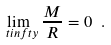Convert formula to latex. <formula><loc_0><loc_0><loc_500><loc_500>\lim _ { \ t i n f t y } \frac { M } { R } = 0 \ .</formula> 